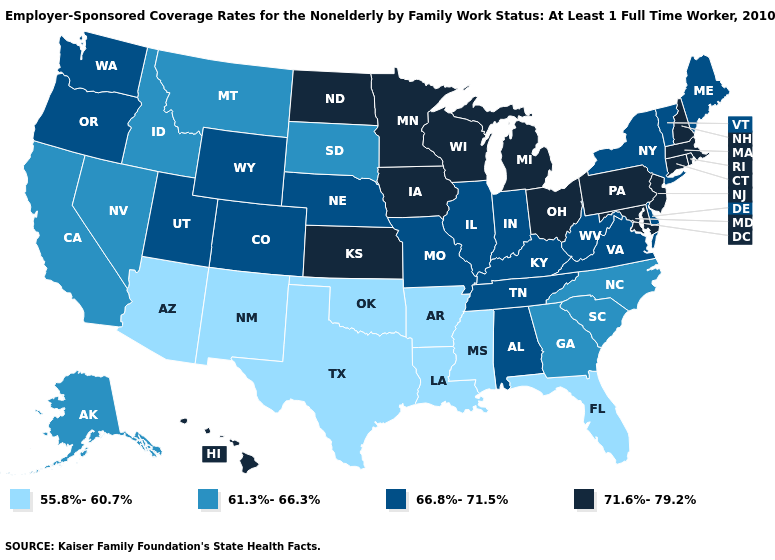Name the states that have a value in the range 61.3%-66.3%?
Be succinct. Alaska, California, Georgia, Idaho, Montana, Nevada, North Carolina, South Carolina, South Dakota. Does Oklahoma have the lowest value in the USA?
Answer briefly. Yes. Name the states that have a value in the range 66.8%-71.5%?
Answer briefly. Alabama, Colorado, Delaware, Illinois, Indiana, Kentucky, Maine, Missouri, Nebraska, New York, Oregon, Tennessee, Utah, Vermont, Virginia, Washington, West Virginia, Wyoming. Does Arizona have the lowest value in the West?
Concise answer only. Yes. Among the states that border New Mexico , does Texas have the highest value?
Give a very brief answer. No. What is the value of Alabama?
Concise answer only. 66.8%-71.5%. Name the states that have a value in the range 71.6%-79.2%?
Short answer required. Connecticut, Hawaii, Iowa, Kansas, Maryland, Massachusetts, Michigan, Minnesota, New Hampshire, New Jersey, North Dakota, Ohio, Pennsylvania, Rhode Island, Wisconsin. Name the states that have a value in the range 71.6%-79.2%?
Concise answer only. Connecticut, Hawaii, Iowa, Kansas, Maryland, Massachusetts, Michigan, Minnesota, New Hampshire, New Jersey, North Dakota, Ohio, Pennsylvania, Rhode Island, Wisconsin. Name the states that have a value in the range 61.3%-66.3%?
Concise answer only. Alaska, California, Georgia, Idaho, Montana, Nevada, North Carolina, South Carolina, South Dakota. Does Kansas have the highest value in the USA?
Keep it brief. Yes. Does New Jersey have the same value as Tennessee?
Give a very brief answer. No. Is the legend a continuous bar?
Quick response, please. No. What is the lowest value in states that border Maryland?
Be succinct. 66.8%-71.5%. Does Missouri have the same value as New York?
Write a very short answer. Yes. Does Oregon have the highest value in the USA?
Concise answer only. No. 